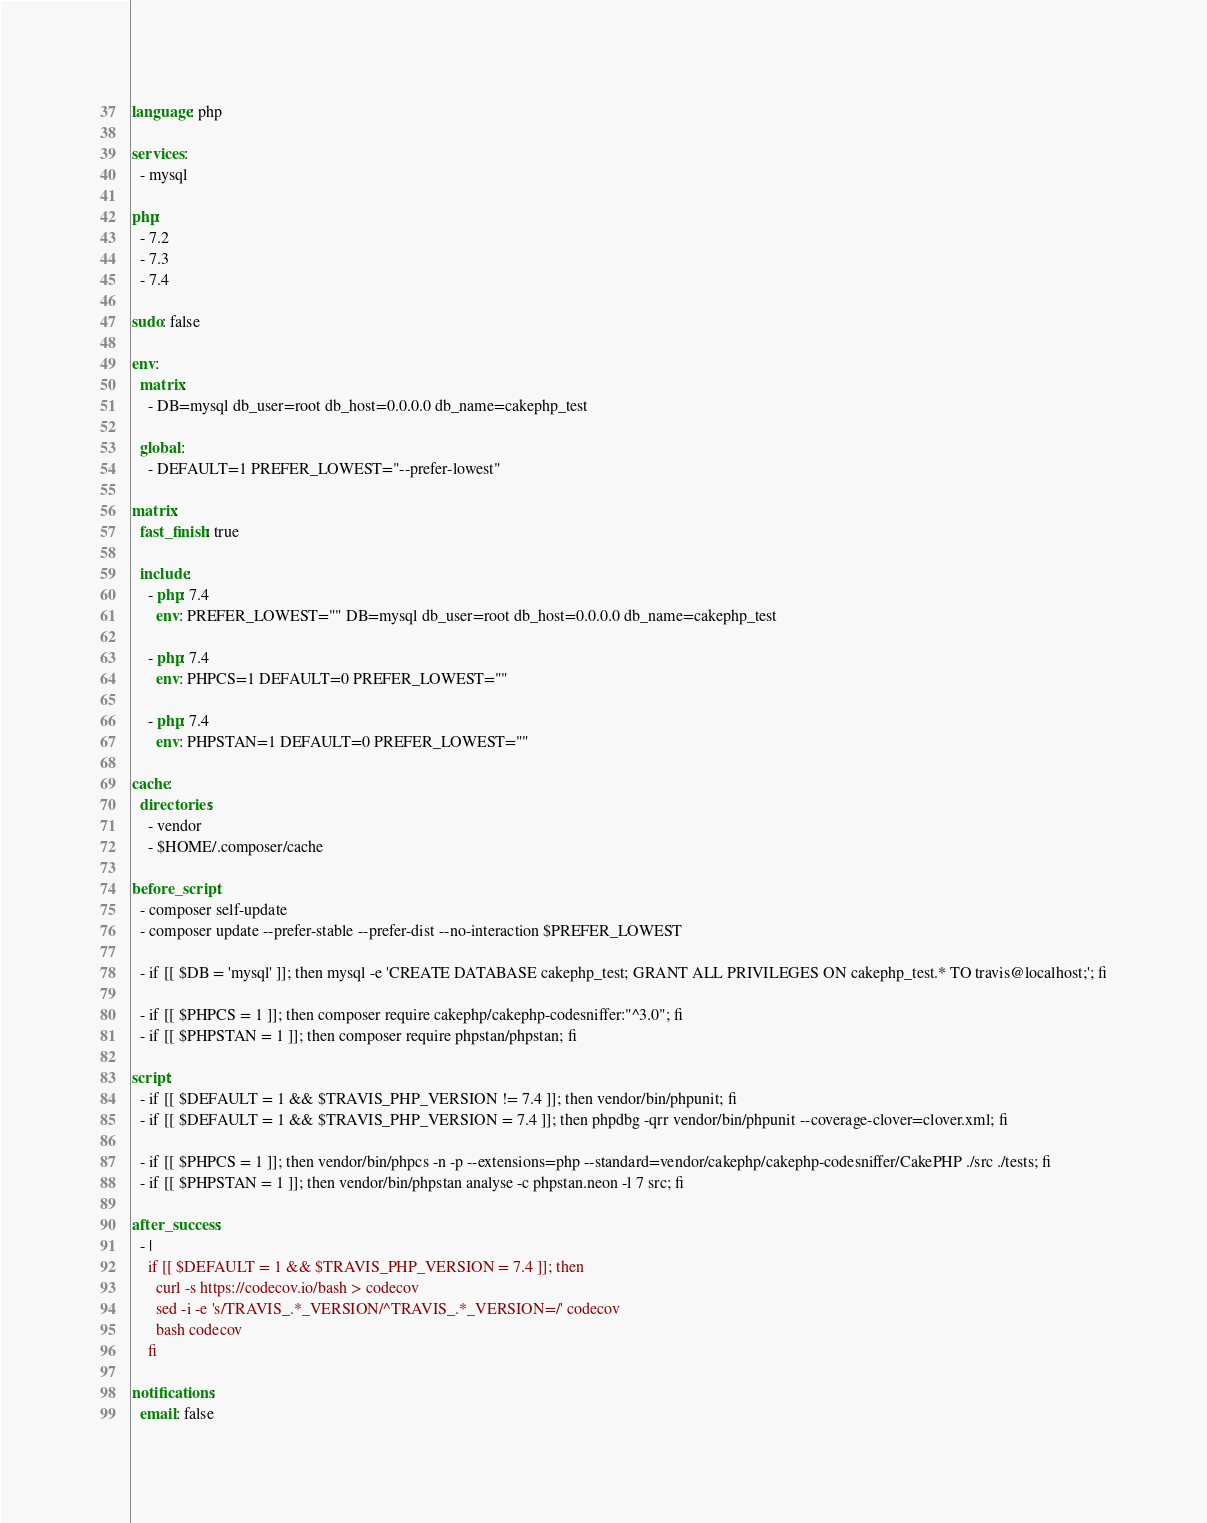Convert code to text. <code><loc_0><loc_0><loc_500><loc_500><_YAML_>language: php

services:
  - mysql

php:
  - 7.2
  - 7.3
  - 7.4

sudo: false

env:
  matrix:
    - DB=mysql db_user=root db_host=0.0.0.0 db_name=cakephp_test

  global:
    - DEFAULT=1 PREFER_LOWEST="--prefer-lowest"

matrix:
  fast_finish: true

  include:
    - php: 7.4
      env: PREFER_LOWEST="" DB=mysql db_user=root db_host=0.0.0.0 db_name=cakephp_test

    - php: 7.4
      env: PHPCS=1 DEFAULT=0 PREFER_LOWEST=""

    - php: 7.4
      env: PHPSTAN=1 DEFAULT=0 PREFER_LOWEST=""

cache:
  directories:
    - vendor
    - $HOME/.composer/cache

before_script:
  - composer self-update
  - composer update --prefer-stable --prefer-dist --no-interaction $PREFER_LOWEST

  - if [[ $DB = 'mysql' ]]; then mysql -e 'CREATE DATABASE cakephp_test; GRANT ALL PRIVILEGES ON cakephp_test.* TO travis@localhost;'; fi

  - if [[ $PHPCS = 1 ]]; then composer require cakephp/cakephp-codesniffer:"^3.0"; fi
  - if [[ $PHPSTAN = 1 ]]; then composer require phpstan/phpstan; fi

script:
  - if [[ $DEFAULT = 1 && $TRAVIS_PHP_VERSION != 7.4 ]]; then vendor/bin/phpunit; fi
  - if [[ $DEFAULT = 1 && $TRAVIS_PHP_VERSION = 7.4 ]]; then phpdbg -qrr vendor/bin/phpunit --coverage-clover=clover.xml; fi

  - if [[ $PHPCS = 1 ]]; then vendor/bin/phpcs -n -p --extensions=php --standard=vendor/cakephp/cakephp-codesniffer/CakePHP ./src ./tests; fi
  - if [[ $PHPSTAN = 1 ]]; then vendor/bin/phpstan analyse -c phpstan.neon -l 7 src; fi

after_success:
  - |
    if [[ $DEFAULT = 1 && $TRAVIS_PHP_VERSION = 7.4 ]]; then
      curl -s https://codecov.io/bash > codecov
      sed -i -e 's/TRAVIS_.*_VERSION/^TRAVIS_.*_VERSION=/' codecov
      bash codecov
    fi

notifications:
  email: false
</code> 